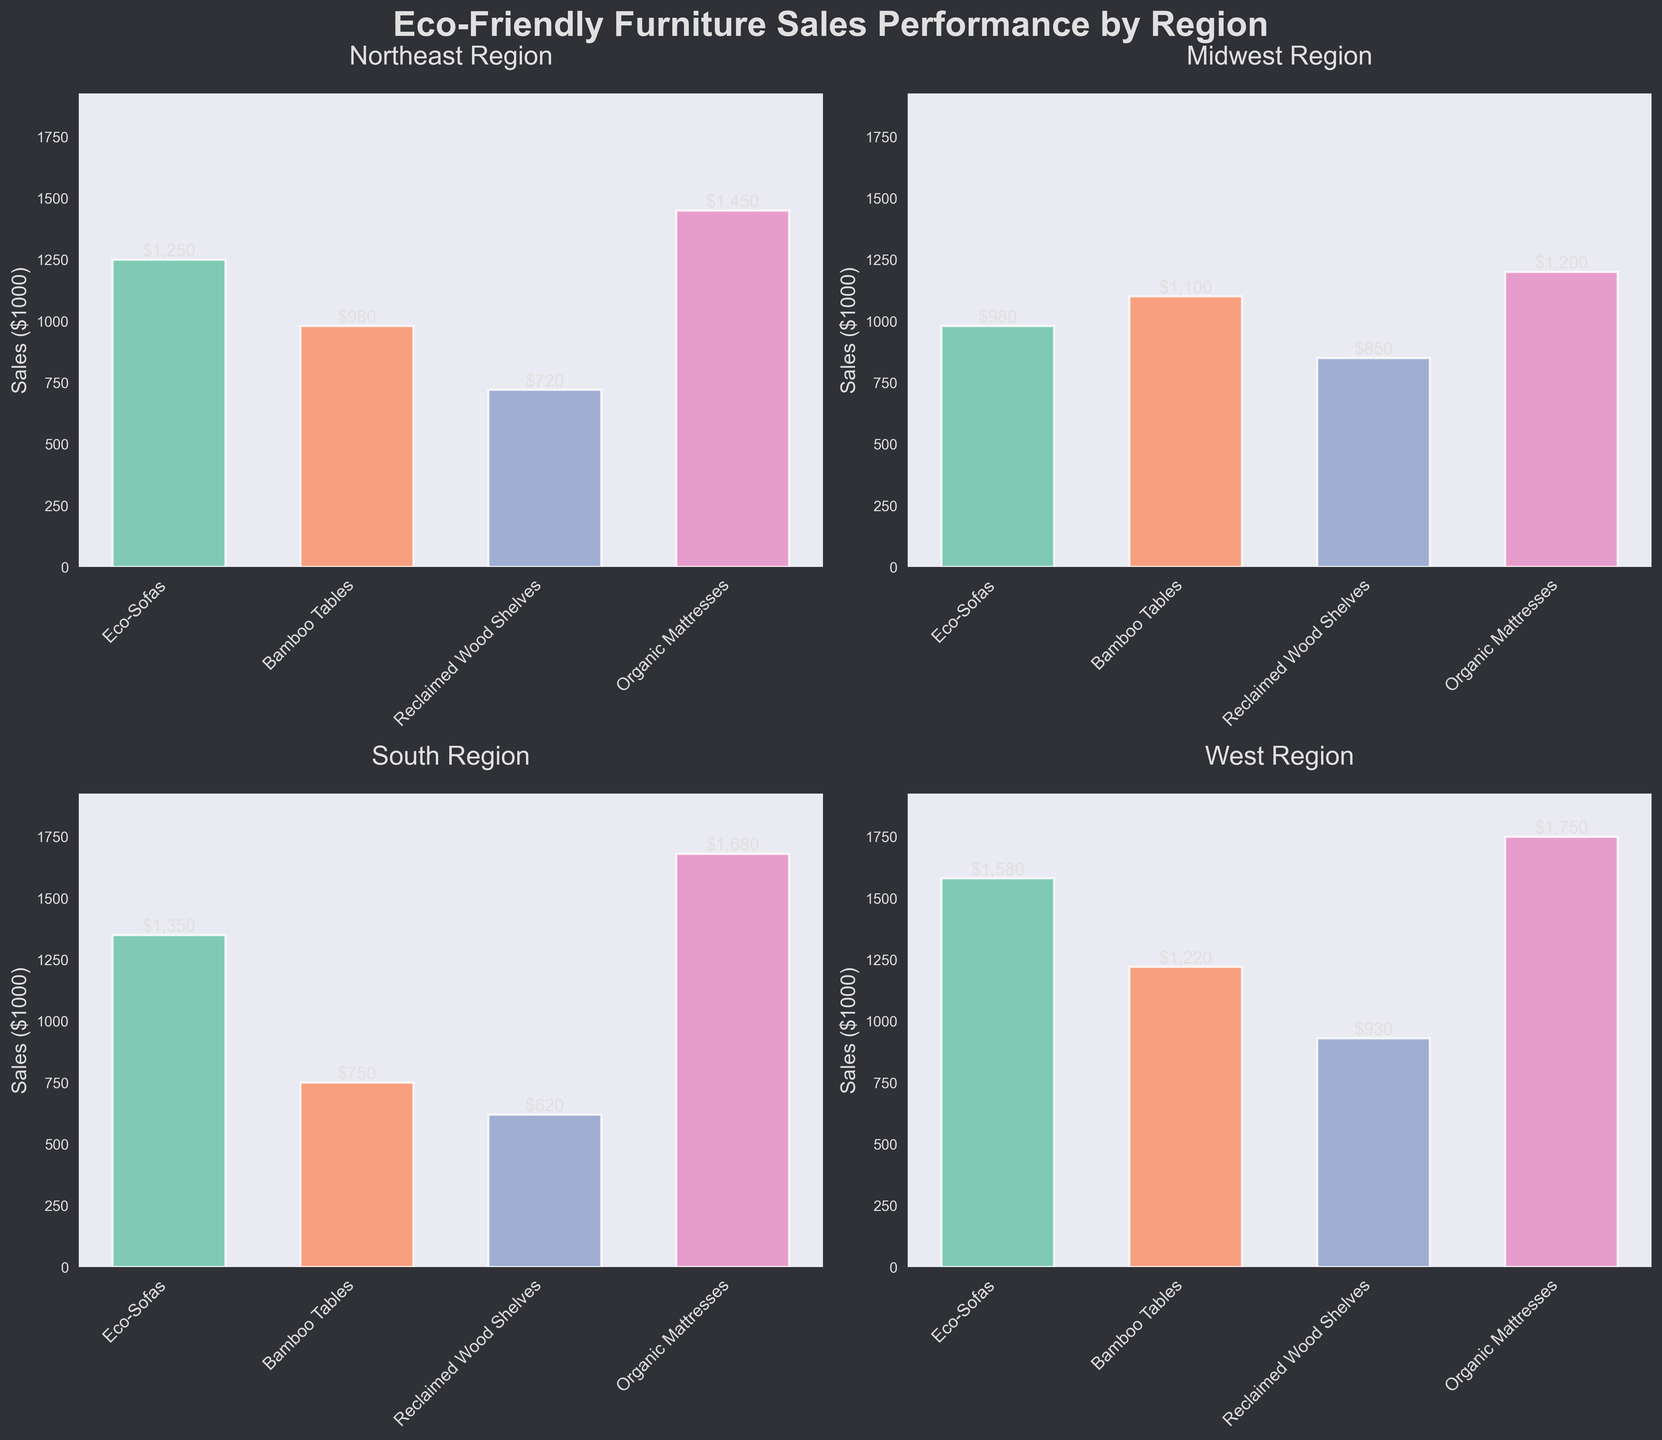what is the title of the figure? The title of the figure summarily tells what the plot is about and can typically be found on the top of the figure. Here, the title is written in a larger and bold font for emphasis.
Answer: Eco-Friendly Furniture Sales Performance by Region which region has the highest sales for eco-sofas? To find this, compare the heights of the bar representing Eco-Sofas across the four regions. The region with the tallest bar has the highest sales.
Answer: West which product category has the lowest sales in the South region? Look at the South Region subplot and compare the heights of the bars for each product category. The category with the shortest bar has the lowest sales.
Answer: Reclaimed Wood Shelves what is the total sales of Organic Mattresses across all regions? Add the sales values for Organic Mattresses in each region: 1450 (Northeast) + 1200 (Midwest) + 1680 (South) + 1750 (West).
Answer: 6080 are sales generally higher in the West or Midwest? Analyze the overall heights of the bars in the West and Midwest subplots. The region with generally taller bars has higher sales.
Answer: West which region has the most balanced sales across categories? Check which subplot has bars of roughly similar heights for all product categories, indicating balanced sales.
Answer: Midwest does the Northeast region have higher sales for Bamboo Tables or Organic Mattresses? Compare the heights of the bars for Bamboo Tables and Organic Mattresses in the Northeast subplot. The taller bar represents the higher sales.
Answer: Organic Mattresses rank the regions based on their sales for Reclaimed Wood Shelves, from highest to lowest. Compare the heights of the bars for Reclaimed Wood Shelves in the four regions and rank them accordingly. The heights are: West (930), Midwest (850), Northeast (720), South (620).
Answer: West > Midwest > Northeast > South what is the average sales of Bamboo Tables across all regions? Add the sales values for Bamboo Tables in each region: 980 (Northeast) + 1100 (Midwest) + 750 (South) + 1220 (West) and then divide by the number of regions (4).
Answer: 1012.5 